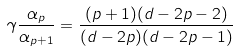<formula> <loc_0><loc_0><loc_500><loc_500>\gamma \frac { \alpha _ { p } } { \alpha _ { p + 1 } } = \frac { ( p + 1 ) ( d - 2 p - 2 ) } { ( d - 2 p ) ( d - 2 p - 1 ) }</formula> 